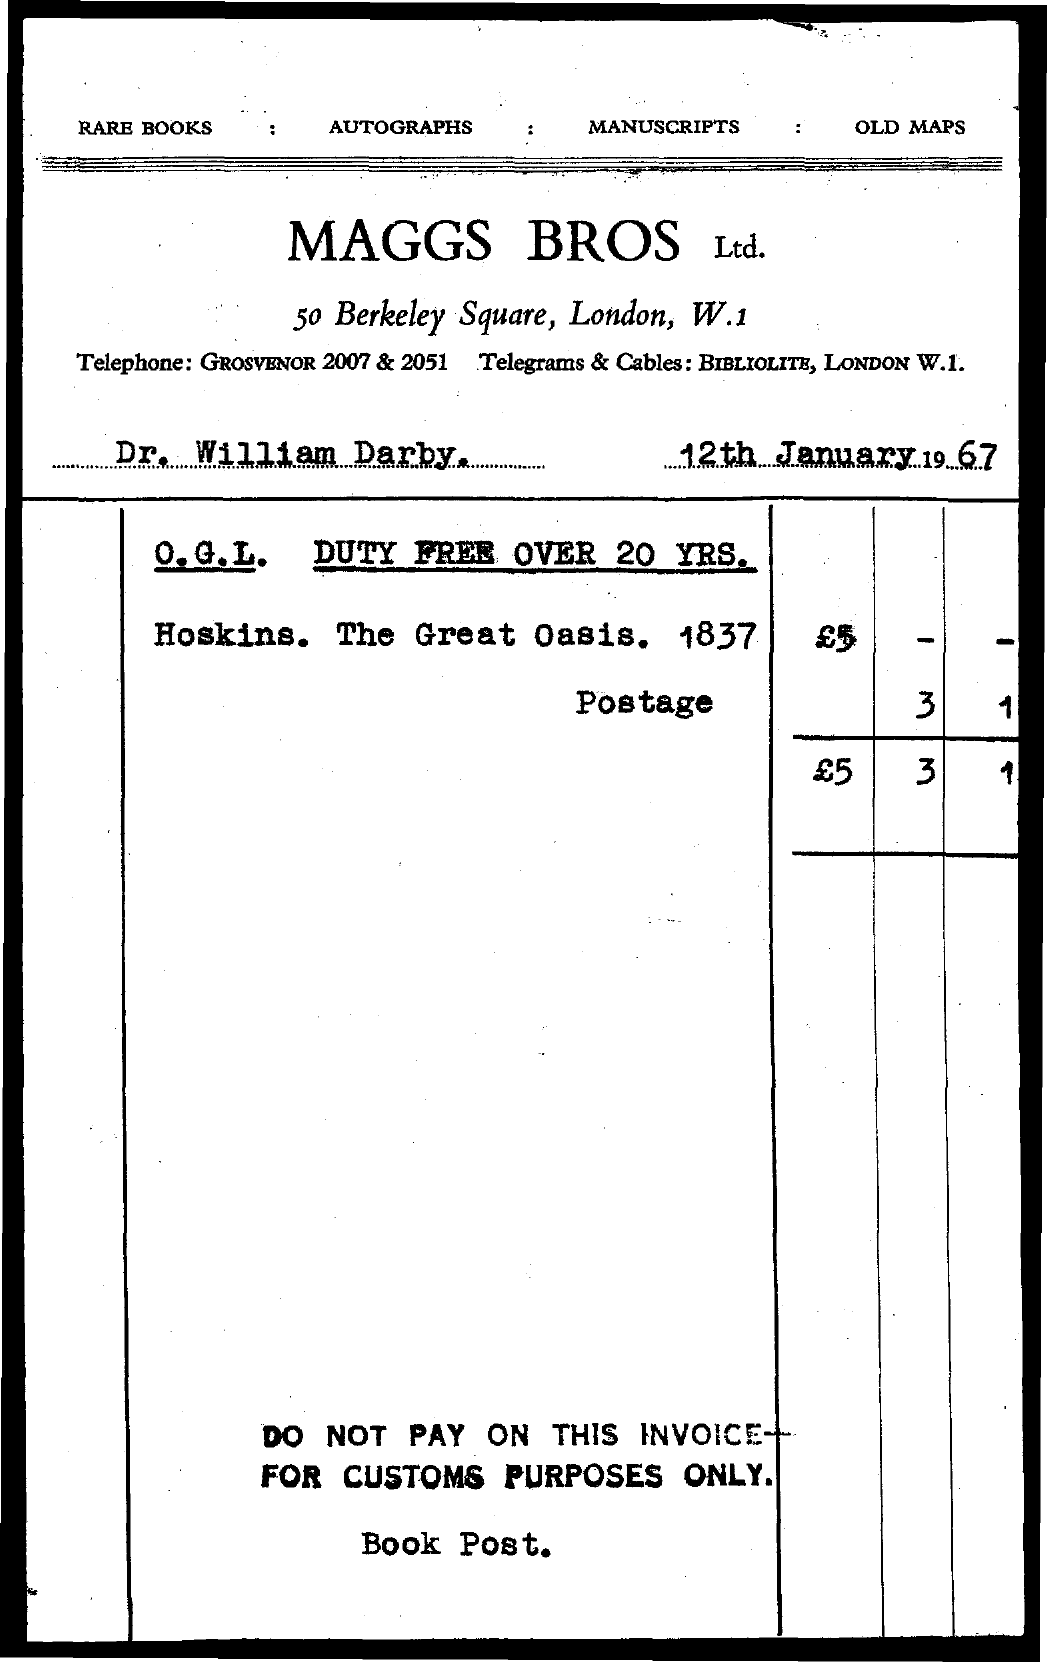What is name of the organization involved?
Ensure brevity in your answer.  MAGGS BROS Ltd. What is the date mentioned in the document?
Ensure brevity in your answer.  12th January 1967. 